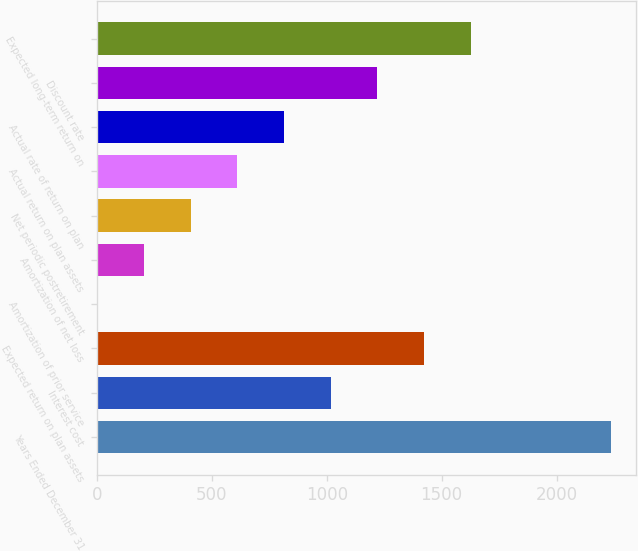<chart> <loc_0><loc_0><loc_500><loc_500><bar_chart><fcel>Years Ended December 31<fcel>Interest cost<fcel>Expected return on plan assets<fcel>Amortization of prior service<fcel>Amortization of net loss<fcel>Net periodic postretirement<fcel>Actual return on plan assets<fcel>Actual rate of return on plan<fcel>Discount rate<fcel>Expected long-term return on<nl><fcel>2236.2<fcel>1017<fcel>1423.4<fcel>1<fcel>204.2<fcel>407.4<fcel>610.6<fcel>813.8<fcel>1220.2<fcel>1626.6<nl></chart> 